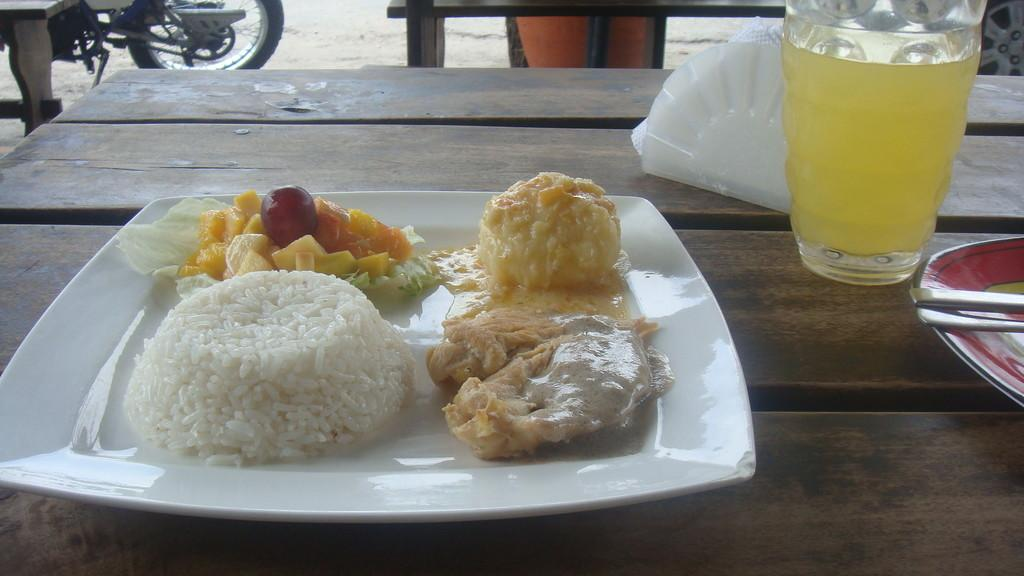What is on the plate that is visible in the image? There is a plate of food in the image. Are there any other plates visible in the image? Yes, there is another plate on the table. What is in the glass that is visible in the image? There is a glass of fruit juice in the image. What can be seen in the background of the image? There is a motorcycle in the background of the image. Which direction is the banana pointing in the image? There is no banana present in the image, so it cannot be determined which direction it would be pointing. 